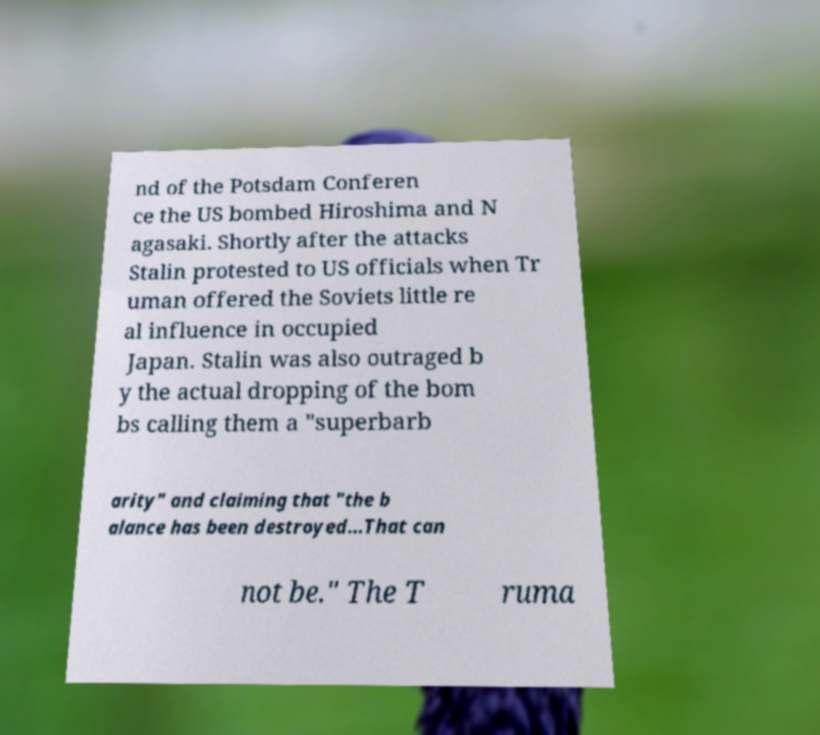Can you read and provide the text displayed in the image?This photo seems to have some interesting text. Can you extract and type it out for me? nd of the Potsdam Conferen ce the US bombed Hiroshima and N agasaki. Shortly after the attacks Stalin protested to US officials when Tr uman offered the Soviets little re al influence in occupied Japan. Stalin was also outraged b y the actual dropping of the bom bs calling them a "superbarb arity" and claiming that "the b alance has been destroyed...That can not be." The T ruma 